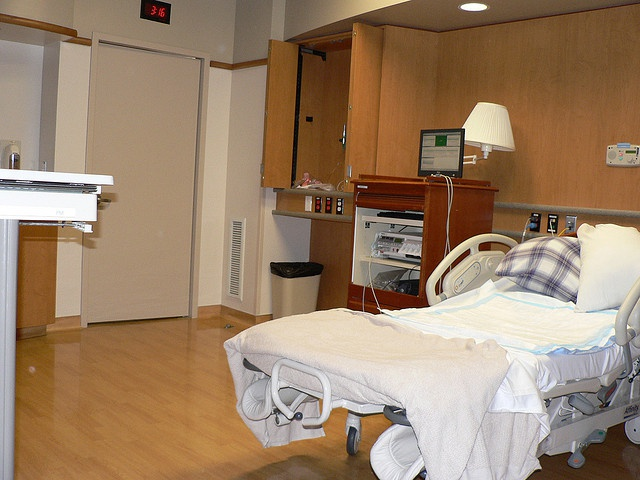Describe the objects in this image and their specific colors. I can see bed in gray, lightgray, darkgray, and tan tones, tv in gray and black tones, and keyboard in gray and black tones in this image. 